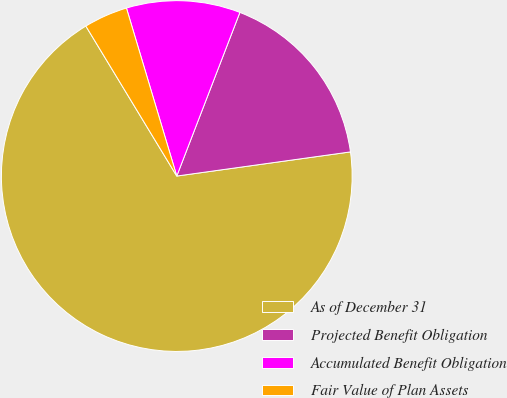<chart> <loc_0><loc_0><loc_500><loc_500><pie_chart><fcel>As of December 31<fcel>Projected Benefit Obligation<fcel>Accumulated Benefit Obligation<fcel>Fair Value of Plan Assets<nl><fcel>68.52%<fcel>16.94%<fcel>10.49%<fcel>4.04%<nl></chart> 